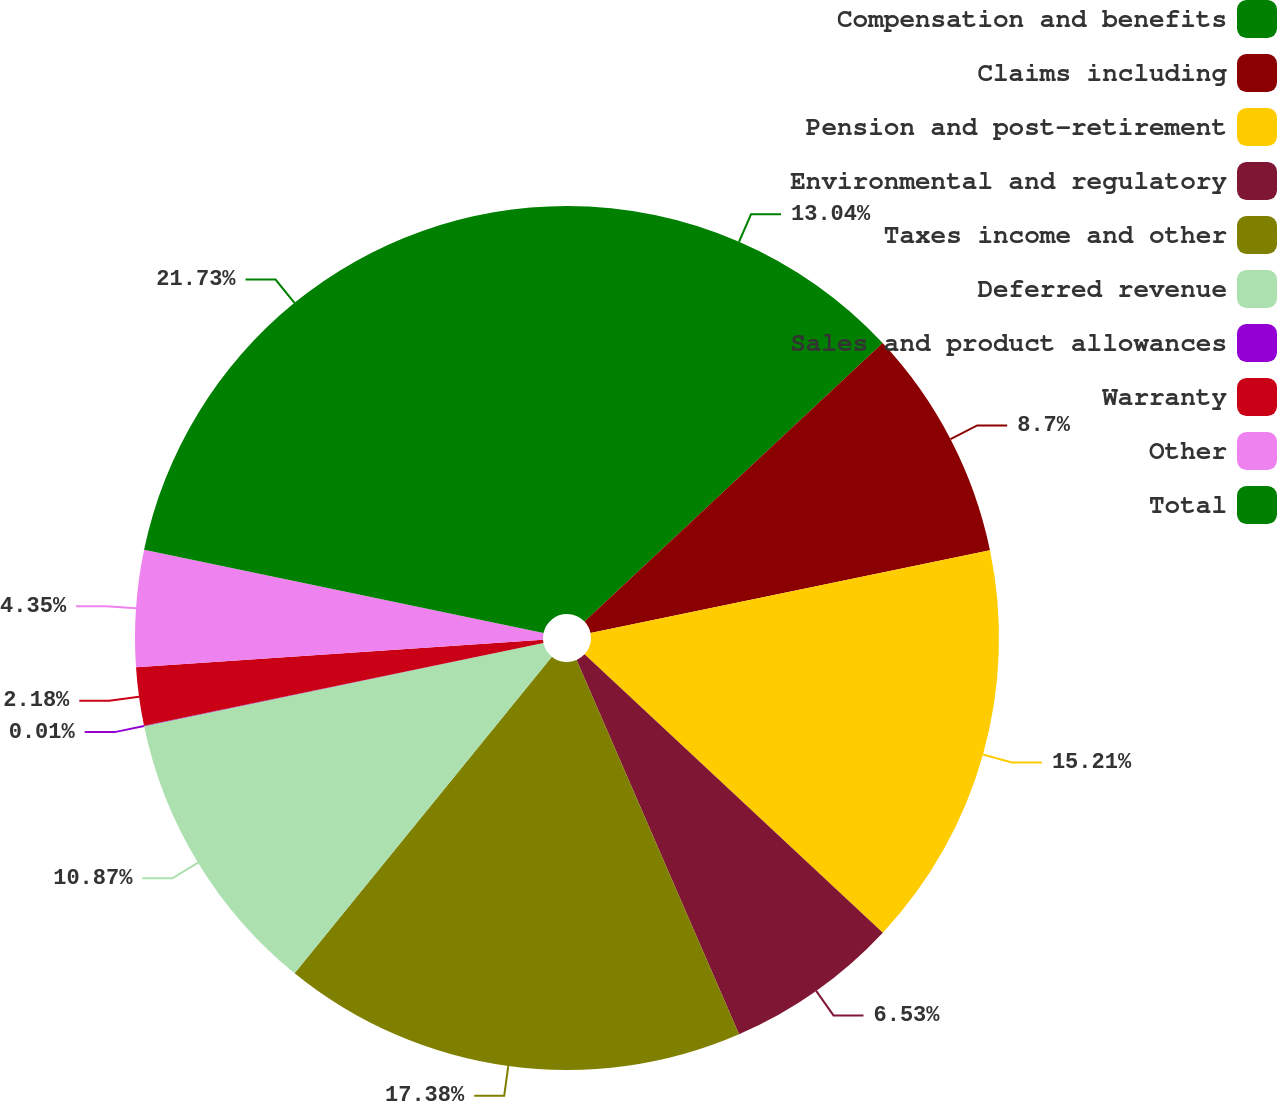<chart> <loc_0><loc_0><loc_500><loc_500><pie_chart><fcel>Compensation and benefits<fcel>Claims including<fcel>Pension and post-retirement<fcel>Environmental and regulatory<fcel>Taxes income and other<fcel>Deferred revenue<fcel>Sales and product allowances<fcel>Warranty<fcel>Other<fcel>Total<nl><fcel>13.04%<fcel>8.7%<fcel>15.21%<fcel>6.53%<fcel>17.38%<fcel>10.87%<fcel>0.01%<fcel>2.18%<fcel>4.35%<fcel>21.73%<nl></chart> 